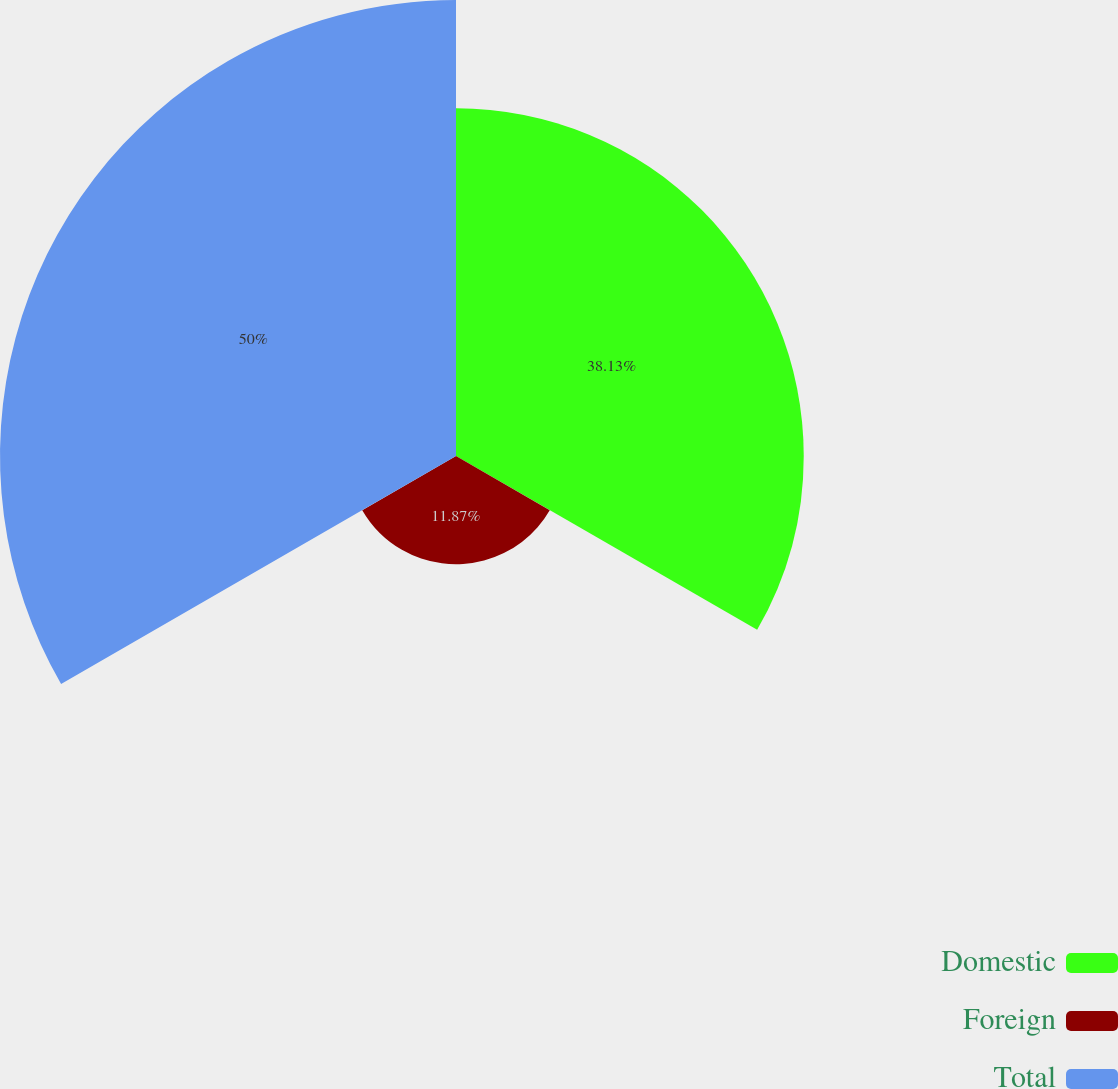<chart> <loc_0><loc_0><loc_500><loc_500><pie_chart><fcel>Domestic<fcel>Foreign<fcel>Total<nl><fcel>38.13%<fcel>11.87%<fcel>50.0%<nl></chart> 